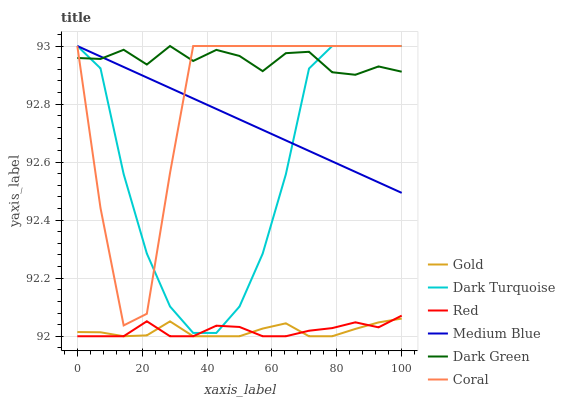Does Dark Turquoise have the minimum area under the curve?
Answer yes or no. No. Does Dark Turquoise have the maximum area under the curve?
Answer yes or no. No. Is Dark Turquoise the smoothest?
Answer yes or no. No. Is Dark Turquoise the roughest?
Answer yes or no. No. Does Dark Turquoise have the lowest value?
Answer yes or no. No. Does Red have the highest value?
Answer yes or no. No. Is Red less than Coral?
Answer yes or no. Yes. Is Medium Blue greater than Gold?
Answer yes or no. Yes. Does Red intersect Coral?
Answer yes or no. No. 